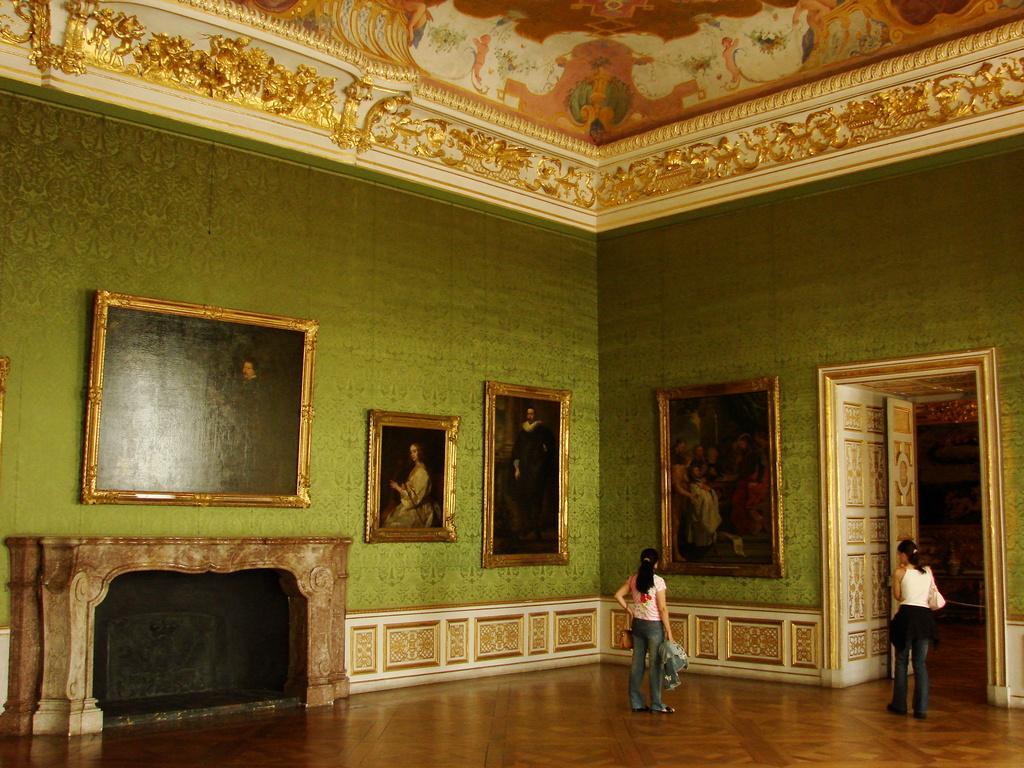Can you describe this image briefly? In this picture, we can see the inner view of a room, and we can see two persons with some objects on the ground, we can see the wall with photo frames, door, and fire place, we can see the roof with some design. 